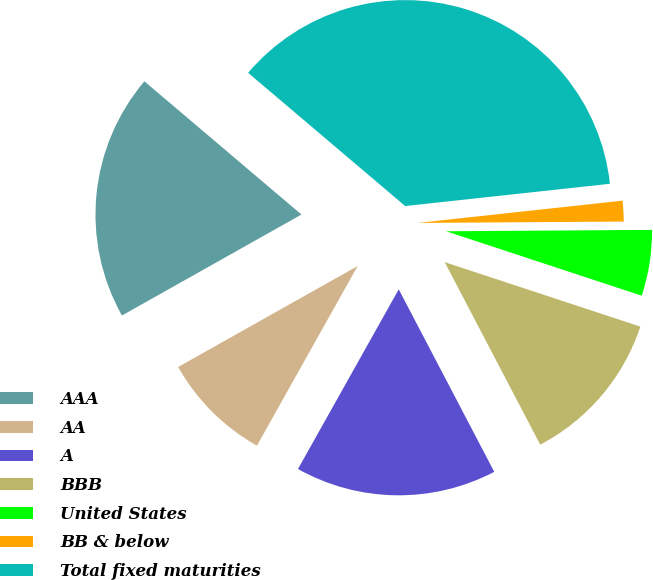<chart> <loc_0><loc_0><loc_500><loc_500><pie_chart><fcel>AAA<fcel>AA<fcel>A<fcel>BBB<fcel>United States<fcel>BB & below<fcel>Total fixed maturities<nl><fcel>19.35%<fcel>8.71%<fcel>15.81%<fcel>12.26%<fcel>5.17%<fcel>1.62%<fcel>37.08%<nl></chart> 